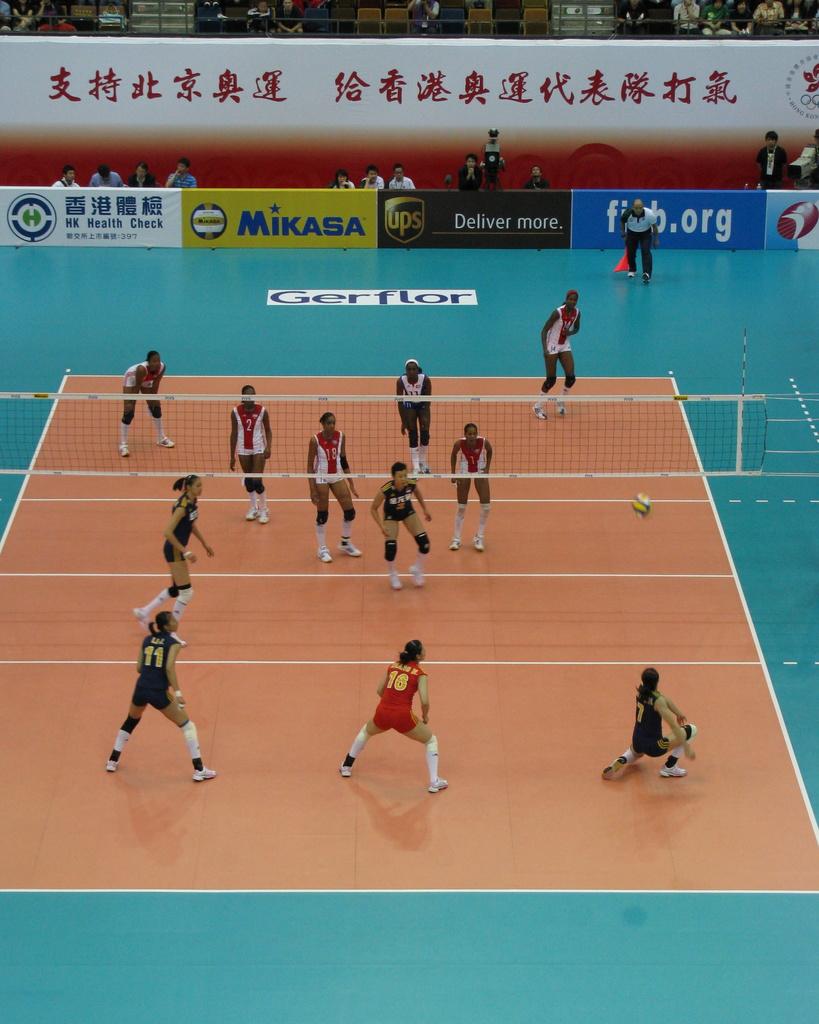What company delivers more?
Make the answer very short. Ups. Is player 11 on the court?
Ensure brevity in your answer.  Yes. 